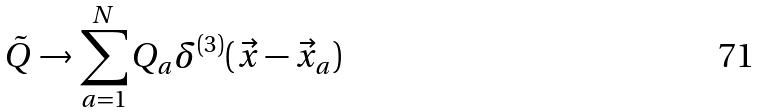Convert formula to latex. <formula><loc_0><loc_0><loc_500><loc_500>\tilde { Q } \to \sum _ { a = 1 } ^ { N } Q _ { a } \delta ^ { ( 3 ) } ( \vec { x } - \vec { x } _ { a } )</formula> 